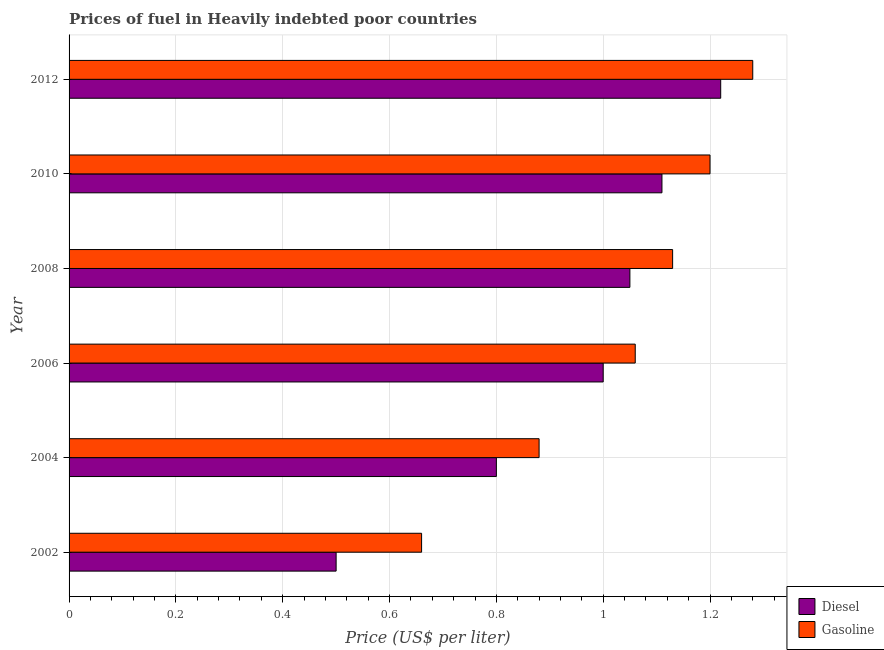How many different coloured bars are there?
Your answer should be very brief. 2. How many groups of bars are there?
Give a very brief answer. 6. Are the number of bars per tick equal to the number of legend labels?
Keep it short and to the point. Yes. How many bars are there on the 5th tick from the top?
Provide a short and direct response. 2. In how many cases, is the number of bars for a given year not equal to the number of legend labels?
Ensure brevity in your answer.  0. Across all years, what is the maximum gasoline price?
Your answer should be compact. 1.28. Across all years, what is the minimum diesel price?
Make the answer very short. 0.5. In which year was the gasoline price maximum?
Offer a very short reply. 2012. In which year was the gasoline price minimum?
Ensure brevity in your answer.  2002. What is the total gasoline price in the graph?
Keep it short and to the point. 6.21. What is the difference between the diesel price in 2004 and that in 2010?
Make the answer very short. -0.31. What is the difference between the gasoline price in 2006 and the diesel price in 2002?
Offer a very short reply. 0.56. What is the average gasoline price per year?
Provide a short and direct response. 1.03. In the year 2004, what is the difference between the gasoline price and diesel price?
Your answer should be compact. 0.08. In how many years, is the diesel price greater than 0.2 US$ per litre?
Keep it short and to the point. 6. What is the ratio of the gasoline price in 2002 to that in 2006?
Offer a terse response. 0.62. Is the gasoline price in 2006 less than that in 2008?
Offer a terse response. Yes. What is the difference between the highest and the second highest diesel price?
Your answer should be compact. 0.11. What is the difference between the highest and the lowest gasoline price?
Your answer should be very brief. 0.62. What does the 1st bar from the top in 2012 represents?
Your answer should be compact. Gasoline. What does the 1st bar from the bottom in 2002 represents?
Provide a short and direct response. Diesel. What is the difference between two consecutive major ticks on the X-axis?
Your answer should be very brief. 0.2. Are the values on the major ticks of X-axis written in scientific E-notation?
Provide a succinct answer. No. Does the graph contain any zero values?
Keep it short and to the point. No. Does the graph contain grids?
Ensure brevity in your answer.  Yes. How many legend labels are there?
Provide a short and direct response. 2. How are the legend labels stacked?
Provide a succinct answer. Vertical. What is the title of the graph?
Your response must be concise. Prices of fuel in Heavily indebted poor countries. Does "Male" appear as one of the legend labels in the graph?
Keep it short and to the point. No. What is the label or title of the X-axis?
Make the answer very short. Price (US$ per liter). What is the Price (US$ per liter) of Diesel in 2002?
Your answer should be very brief. 0.5. What is the Price (US$ per liter) of Gasoline in 2002?
Give a very brief answer. 0.66. What is the Price (US$ per liter) in Gasoline in 2006?
Offer a very short reply. 1.06. What is the Price (US$ per liter) in Gasoline in 2008?
Your answer should be compact. 1.13. What is the Price (US$ per liter) of Diesel in 2010?
Ensure brevity in your answer.  1.11. What is the Price (US$ per liter) in Gasoline in 2010?
Make the answer very short. 1.2. What is the Price (US$ per liter) in Diesel in 2012?
Your response must be concise. 1.22. What is the Price (US$ per liter) of Gasoline in 2012?
Offer a very short reply. 1.28. Across all years, what is the maximum Price (US$ per liter) of Diesel?
Ensure brevity in your answer.  1.22. Across all years, what is the maximum Price (US$ per liter) of Gasoline?
Your answer should be very brief. 1.28. Across all years, what is the minimum Price (US$ per liter) in Diesel?
Provide a succinct answer. 0.5. Across all years, what is the minimum Price (US$ per liter) of Gasoline?
Make the answer very short. 0.66. What is the total Price (US$ per liter) in Diesel in the graph?
Provide a succinct answer. 5.68. What is the total Price (US$ per liter) in Gasoline in the graph?
Give a very brief answer. 6.21. What is the difference between the Price (US$ per liter) of Diesel in 2002 and that in 2004?
Your answer should be very brief. -0.3. What is the difference between the Price (US$ per liter) of Gasoline in 2002 and that in 2004?
Your answer should be very brief. -0.22. What is the difference between the Price (US$ per liter) in Diesel in 2002 and that in 2006?
Keep it short and to the point. -0.5. What is the difference between the Price (US$ per liter) of Diesel in 2002 and that in 2008?
Give a very brief answer. -0.55. What is the difference between the Price (US$ per liter) in Gasoline in 2002 and that in 2008?
Provide a short and direct response. -0.47. What is the difference between the Price (US$ per liter) of Diesel in 2002 and that in 2010?
Your answer should be compact. -0.61. What is the difference between the Price (US$ per liter) in Gasoline in 2002 and that in 2010?
Keep it short and to the point. -0.54. What is the difference between the Price (US$ per liter) in Diesel in 2002 and that in 2012?
Keep it short and to the point. -0.72. What is the difference between the Price (US$ per liter) of Gasoline in 2002 and that in 2012?
Provide a succinct answer. -0.62. What is the difference between the Price (US$ per liter) in Diesel in 2004 and that in 2006?
Offer a very short reply. -0.2. What is the difference between the Price (US$ per liter) of Gasoline in 2004 and that in 2006?
Your answer should be compact. -0.18. What is the difference between the Price (US$ per liter) of Diesel in 2004 and that in 2008?
Your answer should be compact. -0.25. What is the difference between the Price (US$ per liter) of Gasoline in 2004 and that in 2008?
Keep it short and to the point. -0.25. What is the difference between the Price (US$ per liter) in Diesel in 2004 and that in 2010?
Offer a terse response. -0.31. What is the difference between the Price (US$ per liter) in Gasoline in 2004 and that in 2010?
Provide a succinct answer. -0.32. What is the difference between the Price (US$ per liter) of Diesel in 2004 and that in 2012?
Your answer should be compact. -0.42. What is the difference between the Price (US$ per liter) in Gasoline in 2004 and that in 2012?
Your response must be concise. -0.4. What is the difference between the Price (US$ per liter) in Diesel in 2006 and that in 2008?
Your answer should be compact. -0.05. What is the difference between the Price (US$ per liter) of Gasoline in 2006 and that in 2008?
Your answer should be compact. -0.07. What is the difference between the Price (US$ per liter) of Diesel in 2006 and that in 2010?
Your answer should be compact. -0.11. What is the difference between the Price (US$ per liter) of Gasoline in 2006 and that in 2010?
Ensure brevity in your answer.  -0.14. What is the difference between the Price (US$ per liter) in Diesel in 2006 and that in 2012?
Your response must be concise. -0.22. What is the difference between the Price (US$ per liter) of Gasoline in 2006 and that in 2012?
Make the answer very short. -0.22. What is the difference between the Price (US$ per liter) of Diesel in 2008 and that in 2010?
Offer a terse response. -0.06. What is the difference between the Price (US$ per liter) of Gasoline in 2008 and that in 2010?
Offer a very short reply. -0.07. What is the difference between the Price (US$ per liter) of Diesel in 2008 and that in 2012?
Your answer should be very brief. -0.17. What is the difference between the Price (US$ per liter) of Gasoline in 2008 and that in 2012?
Your response must be concise. -0.15. What is the difference between the Price (US$ per liter) of Diesel in 2010 and that in 2012?
Offer a terse response. -0.11. What is the difference between the Price (US$ per liter) in Gasoline in 2010 and that in 2012?
Your response must be concise. -0.08. What is the difference between the Price (US$ per liter) in Diesel in 2002 and the Price (US$ per liter) in Gasoline in 2004?
Provide a short and direct response. -0.38. What is the difference between the Price (US$ per liter) of Diesel in 2002 and the Price (US$ per liter) of Gasoline in 2006?
Provide a succinct answer. -0.56. What is the difference between the Price (US$ per liter) in Diesel in 2002 and the Price (US$ per liter) in Gasoline in 2008?
Your response must be concise. -0.63. What is the difference between the Price (US$ per liter) of Diesel in 2002 and the Price (US$ per liter) of Gasoline in 2012?
Ensure brevity in your answer.  -0.78. What is the difference between the Price (US$ per liter) of Diesel in 2004 and the Price (US$ per liter) of Gasoline in 2006?
Provide a succinct answer. -0.26. What is the difference between the Price (US$ per liter) of Diesel in 2004 and the Price (US$ per liter) of Gasoline in 2008?
Keep it short and to the point. -0.33. What is the difference between the Price (US$ per liter) in Diesel in 2004 and the Price (US$ per liter) in Gasoline in 2012?
Provide a succinct answer. -0.48. What is the difference between the Price (US$ per liter) in Diesel in 2006 and the Price (US$ per liter) in Gasoline in 2008?
Ensure brevity in your answer.  -0.13. What is the difference between the Price (US$ per liter) of Diesel in 2006 and the Price (US$ per liter) of Gasoline in 2012?
Offer a very short reply. -0.28. What is the difference between the Price (US$ per liter) in Diesel in 2008 and the Price (US$ per liter) in Gasoline in 2010?
Offer a terse response. -0.15. What is the difference between the Price (US$ per liter) of Diesel in 2008 and the Price (US$ per liter) of Gasoline in 2012?
Provide a succinct answer. -0.23. What is the difference between the Price (US$ per liter) of Diesel in 2010 and the Price (US$ per liter) of Gasoline in 2012?
Offer a terse response. -0.17. What is the average Price (US$ per liter) in Diesel per year?
Offer a very short reply. 0.95. What is the average Price (US$ per liter) in Gasoline per year?
Provide a short and direct response. 1.03. In the year 2002, what is the difference between the Price (US$ per liter) in Diesel and Price (US$ per liter) in Gasoline?
Make the answer very short. -0.16. In the year 2004, what is the difference between the Price (US$ per liter) of Diesel and Price (US$ per liter) of Gasoline?
Offer a terse response. -0.08. In the year 2006, what is the difference between the Price (US$ per liter) in Diesel and Price (US$ per liter) in Gasoline?
Your answer should be very brief. -0.06. In the year 2008, what is the difference between the Price (US$ per liter) in Diesel and Price (US$ per liter) in Gasoline?
Provide a short and direct response. -0.08. In the year 2010, what is the difference between the Price (US$ per liter) in Diesel and Price (US$ per liter) in Gasoline?
Offer a terse response. -0.09. In the year 2012, what is the difference between the Price (US$ per liter) of Diesel and Price (US$ per liter) of Gasoline?
Give a very brief answer. -0.06. What is the ratio of the Price (US$ per liter) of Diesel in 2002 to that in 2006?
Provide a short and direct response. 0.5. What is the ratio of the Price (US$ per liter) in Gasoline in 2002 to that in 2006?
Your response must be concise. 0.62. What is the ratio of the Price (US$ per liter) in Diesel in 2002 to that in 2008?
Keep it short and to the point. 0.48. What is the ratio of the Price (US$ per liter) of Gasoline in 2002 to that in 2008?
Provide a short and direct response. 0.58. What is the ratio of the Price (US$ per liter) of Diesel in 2002 to that in 2010?
Offer a very short reply. 0.45. What is the ratio of the Price (US$ per liter) of Gasoline in 2002 to that in 2010?
Your answer should be compact. 0.55. What is the ratio of the Price (US$ per liter) of Diesel in 2002 to that in 2012?
Keep it short and to the point. 0.41. What is the ratio of the Price (US$ per liter) of Gasoline in 2002 to that in 2012?
Keep it short and to the point. 0.52. What is the ratio of the Price (US$ per liter) of Gasoline in 2004 to that in 2006?
Your response must be concise. 0.83. What is the ratio of the Price (US$ per liter) of Diesel in 2004 to that in 2008?
Give a very brief answer. 0.76. What is the ratio of the Price (US$ per liter) of Gasoline in 2004 to that in 2008?
Provide a short and direct response. 0.78. What is the ratio of the Price (US$ per liter) of Diesel in 2004 to that in 2010?
Ensure brevity in your answer.  0.72. What is the ratio of the Price (US$ per liter) of Gasoline in 2004 to that in 2010?
Ensure brevity in your answer.  0.73. What is the ratio of the Price (US$ per liter) of Diesel in 2004 to that in 2012?
Ensure brevity in your answer.  0.66. What is the ratio of the Price (US$ per liter) of Gasoline in 2004 to that in 2012?
Make the answer very short. 0.69. What is the ratio of the Price (US$ per liter) in Gasoline in 2006 to that in 2008?
Offer a very short reply. 0.94. What is the ratio of the Price (US$ per liter) of Diesel in 2006 to that in 2010?
Your response must be concise. 0.9. What is the ratio of the Price (US$ per liter) in Gasoline in 2006 to that in 2010?
Give a very brief answer. 0.88. What is the ratio of the Price (US$ per liter) of Diesel in 2006 to that in 2012?
Give a very brief answer. 0.82. What is the ratio of the Price (US$ per liter) of Gasoline in 2006 to that in 2012?
Give a very brief answer. 0.83. What is the ratio of the Price (US$ per liter) of Diesel in 2008 to that in 2010?
Your answer should be compact. 0.95. What is the ratio of the Price (US$ per liter) in Gasoline in 2008 to that in 2010?
Offer a very short reply. 0.94. What is the ratio of the Price (US$ per liter) of Diesel in 2008 to that in 2012?
Your answer should be compact. 0.86. What is the ratio of the Price (US$ per liter) of Gasoline in 2008 to that in 2012?
Give a very brief answer. 0.88. What is the ratio of the Price (US$ per liter) in Diesel in 2010 to that in 2012?
Your response must be concise. 0.91. What is the ratio of the Price (US$ per liter) of Gasoline in 2010 to that in 2012?
Your answer should be compact. 0.94. What is the difference between the highest and the second highest Price (US$ per liter) of Diesel?
Make the answer very short. 0.11. What is the difference between the highest and the lowest Price (US$ per liter) in Diesel?
Your response must be concise. 0.72. What is the difference between the highest and the lowest Price (US$ per liter) in Gasoline?
Your answer should be very brief. 0.62. 